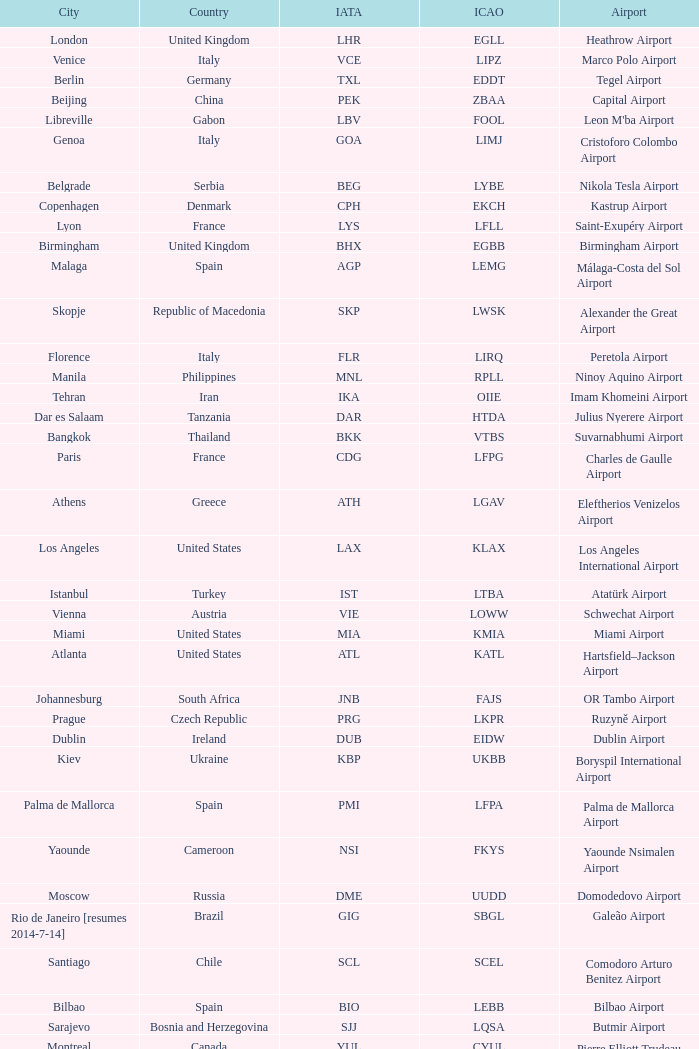What is the ICAO of Lohausen airport? EDDL. 